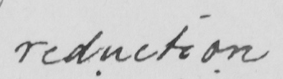Please transcribe the handwritten text in this image. reduction 